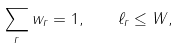<formula> <loc_0><loc_0><loc_500><loc_500>\sum _ { r } w _ { r } = 1 , \quad \ell _ { r } \leq W ,</formula> 